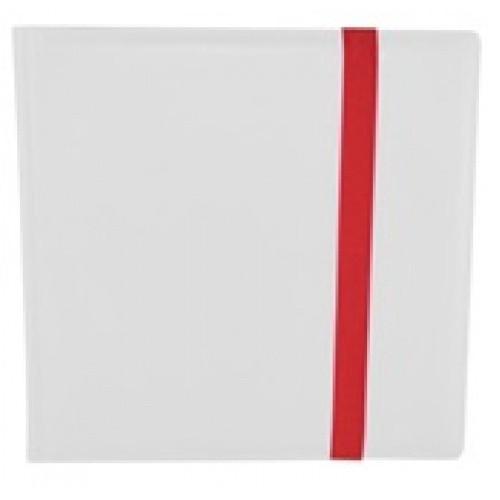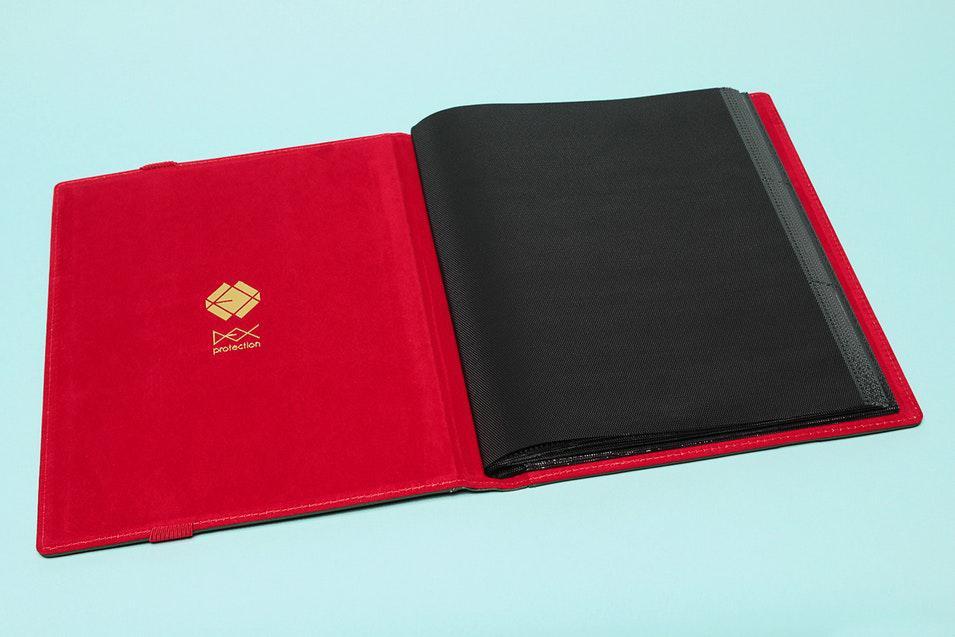The first image is the image on the left, the second image is the image on the right. Given the left and right images, does the statement "In one image, a black album with red trim is show both open and closed." hold true? Answer yes or no. No. 